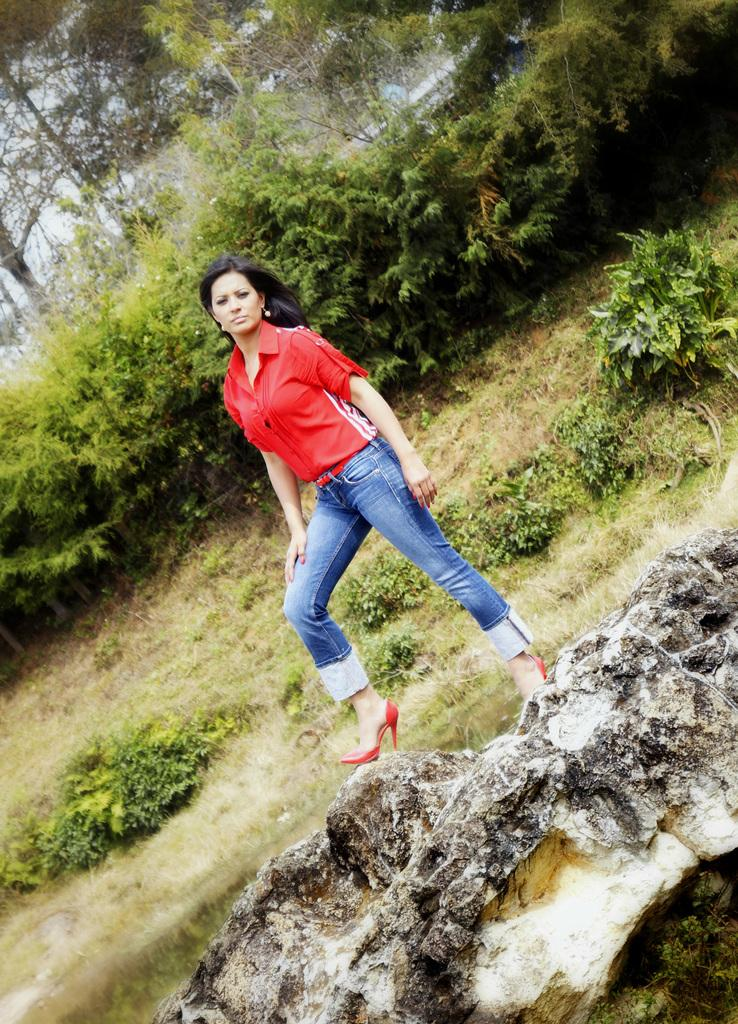What is the woman in the image standing on? The woman is standing on a rock in the image. What can be seen in the image besides the woman? There is water, plants, grass, trees, objects, and the sky visible in the image. Can you describe the natural environment in the background of the image? The background of the image includes grass, trees, and the sky. What is the woman's position relative to the water in the image? The woman is standing on a rock near the water in the image. What type of hook can be seen in the woman's hand in the image? There is no hook present in the woman's hand or in the image. What is the woman eating for dinner in the image? There is no dinner or food visible in the image, and the woman is not eating anything. 